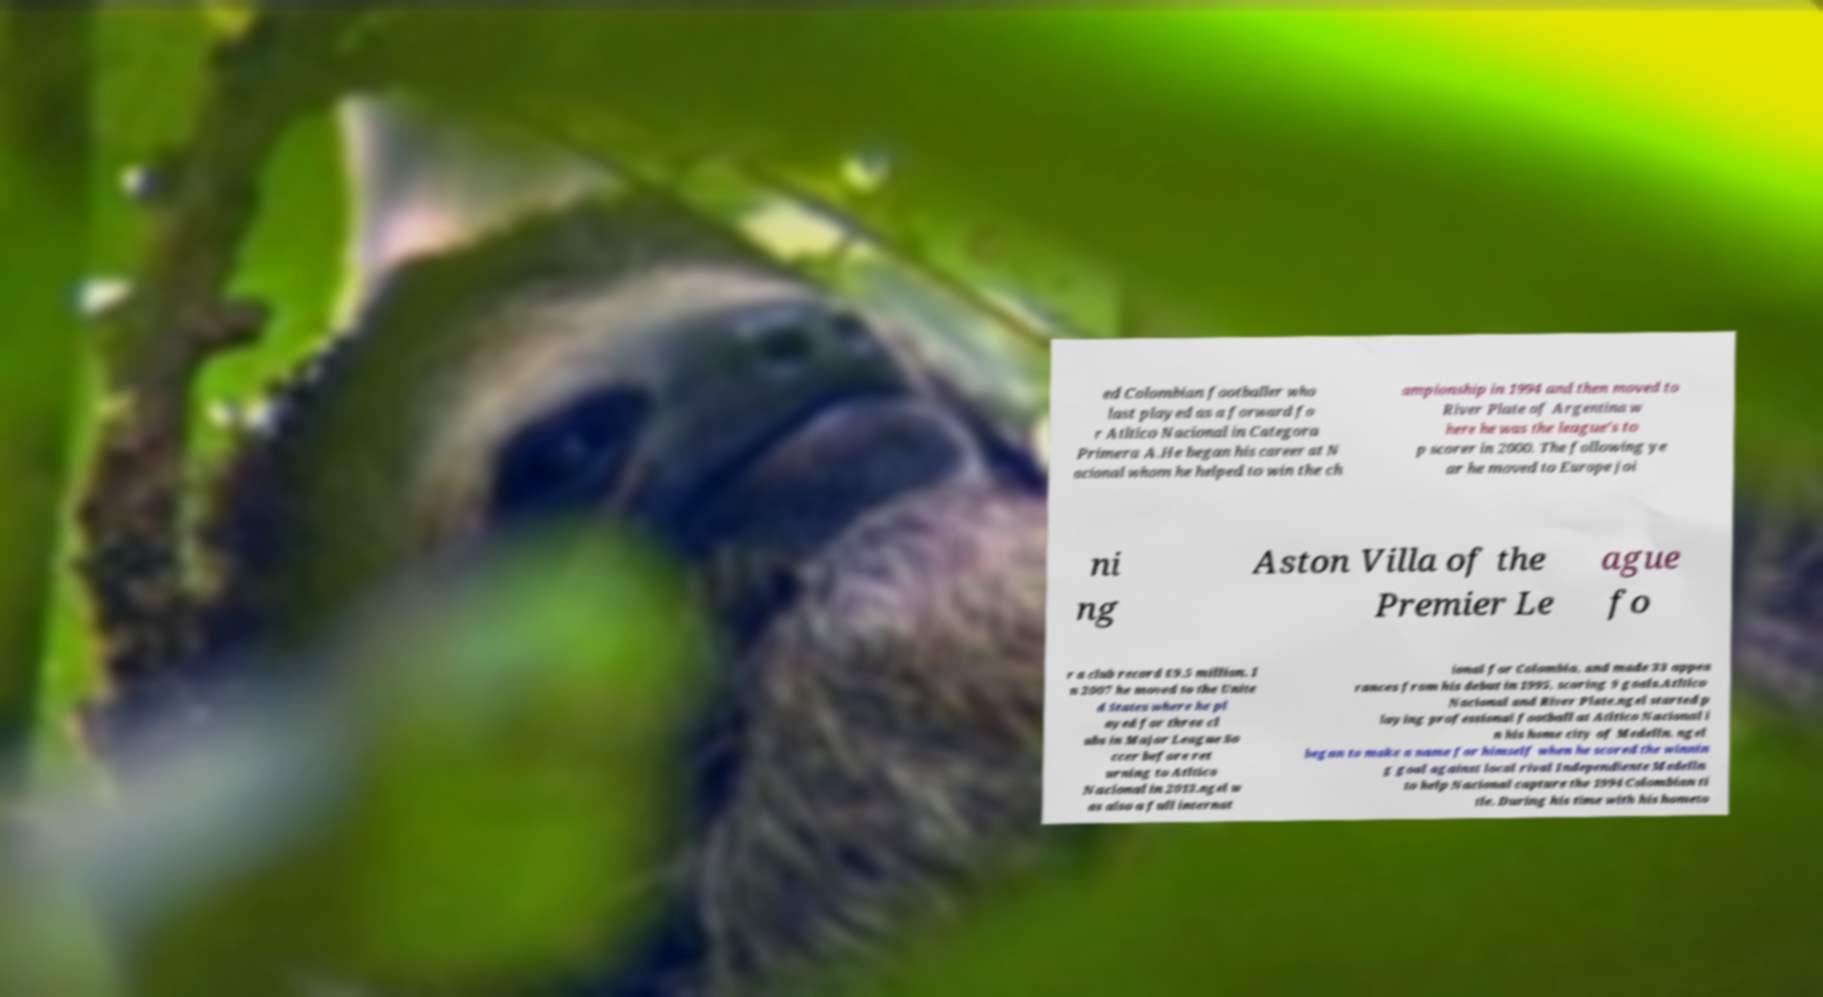What messages or text are displayed in this image? I need them in a readable, typed format. ed Colombian footballer who last played as a forward fo r Atltico Nacional in Categora Primera A.He began his career at N acional whom he helped to win the ch ampionship in 1994 and then moved to River Plate of Argentina w here he was the league's to p scorer in 2000. The following ye ar he moved to Europe joi ni ng Aston Villa of the Premier Le ague fo r a club record £9.5 million. I n 2007 he moved to the Unite d States where he pl ayed for three cl ubs in Major League So ccer before ret urning to Atltico Nacional in 2013.ngel w as also a full internat ional for Colombia, and made 33 appea rances from his debut in 1995, scoring 9 goals.Atltico Nacional and River Plate.ngel started p laying professional football at Atltico Nacional i n his home city of Medelln. ngel began to make a name for himself when he scored the winnin g goal against local rival Independiente Medelln to help Nacional capture the 1994 Colombian ti tle. During his time with his hometo 